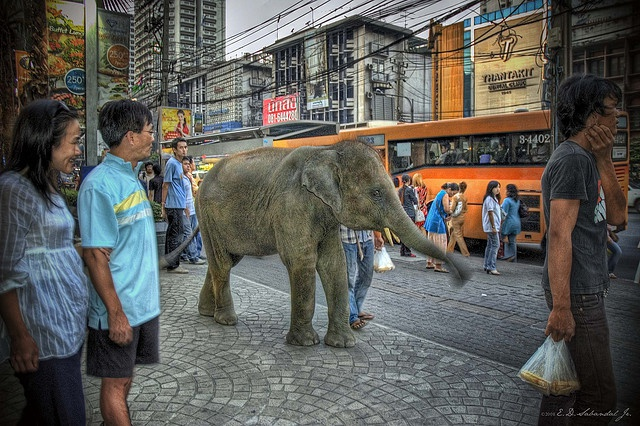Describe the objects in this image and their specific colors. I can see elephant in black, gray, darkgreen, and darkgray tones, people in black, maroon, gray, and brown tones, people in black and gray tones, people in black, lightblue, and gray tones, and bus in black, brown, gray, and red tones in this image. 